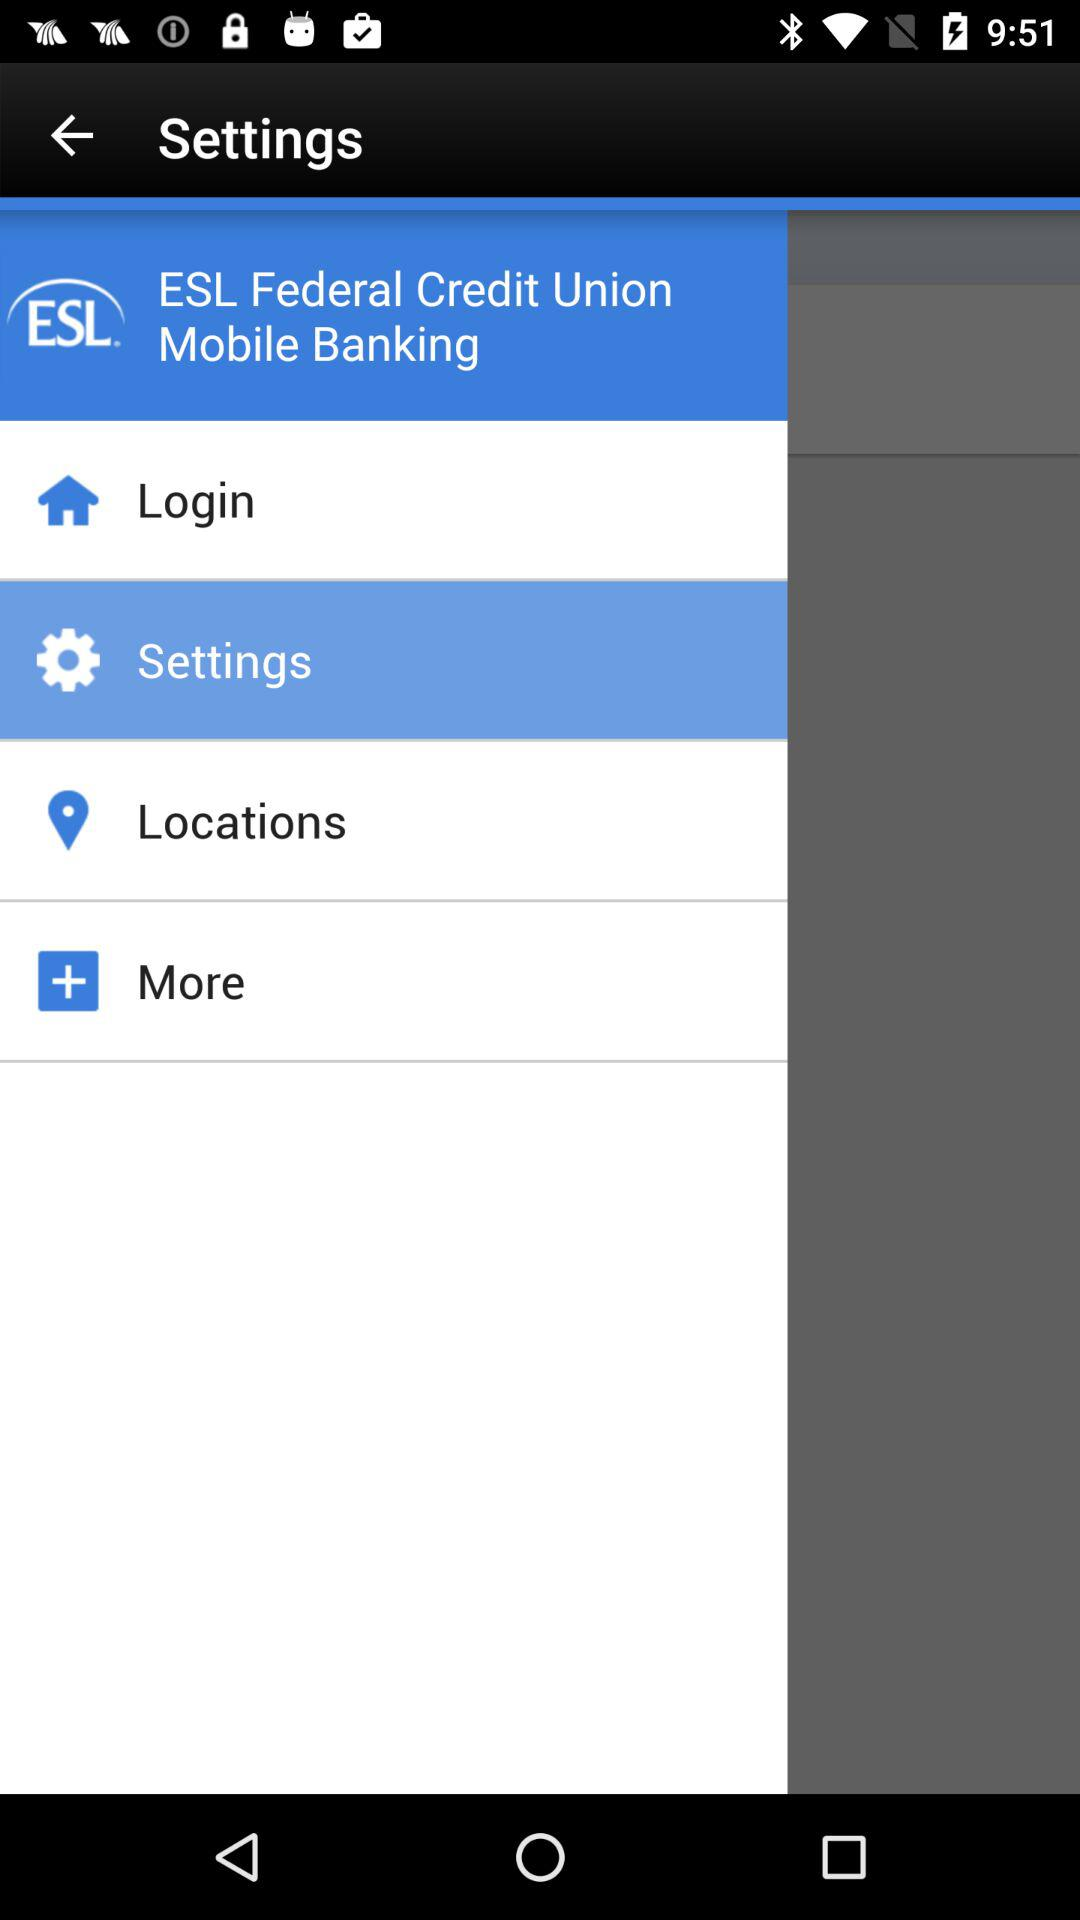What is the name of the application? The name of the application is "ESL Federal Credit Union Mobile Banking". 